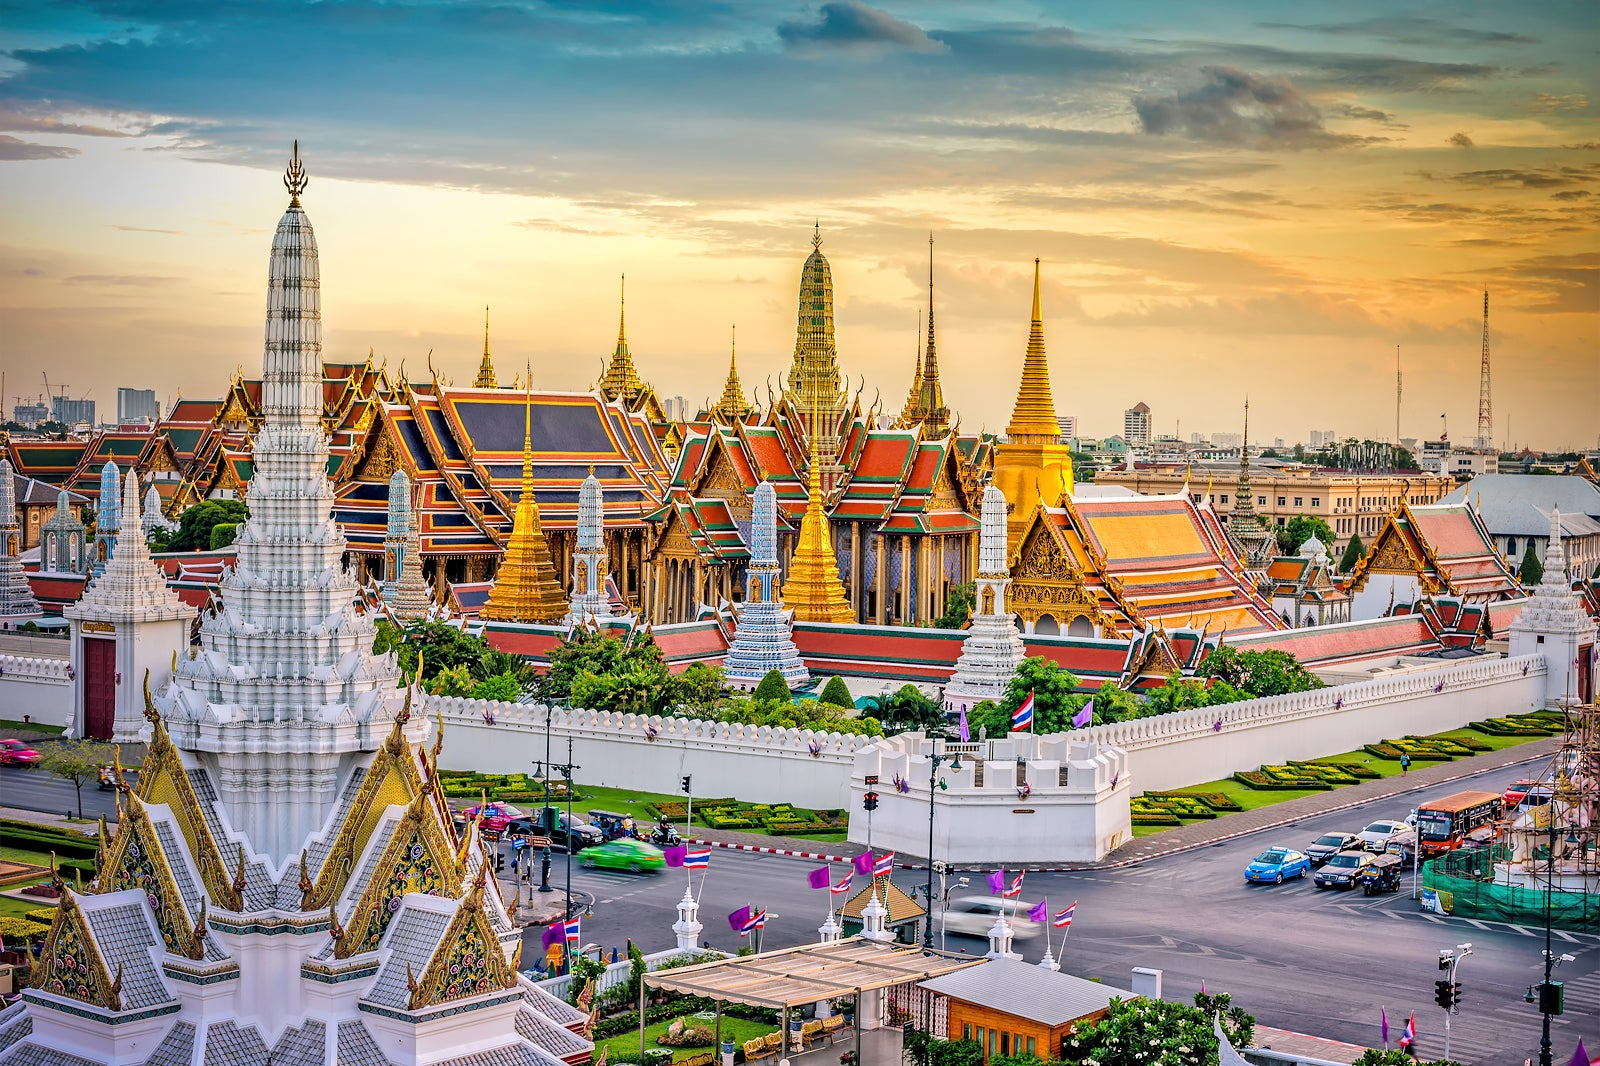Compare the architectural styles of the Grand Palace in Bangkok with any other famous historical palaces. Comparing the Grand Palace in Bangkok with other famous historical palaces such as the Palace of Versailles in France or the Forbidden City in China reveals diverse architectural styles rooted in cultural heritage. The Grand Palace is quintessentially Thai, with its vibrant use of colors, intricate roof designs, and an abundance of gilded elements. The Palace of Versailles showcases classical French architecture with grandiose halls, ornate Baroque details, and expansive gardens. Meanwhile, the Forbidden City is characterized by traditional Chinese architecture, with its symmetrical harmony, tiered roofs, and imperial red and gold colors. Each palace, serving as a seat of power and culture, encapsulates the unique artistic expressions and historical contexts of their respective societies. 